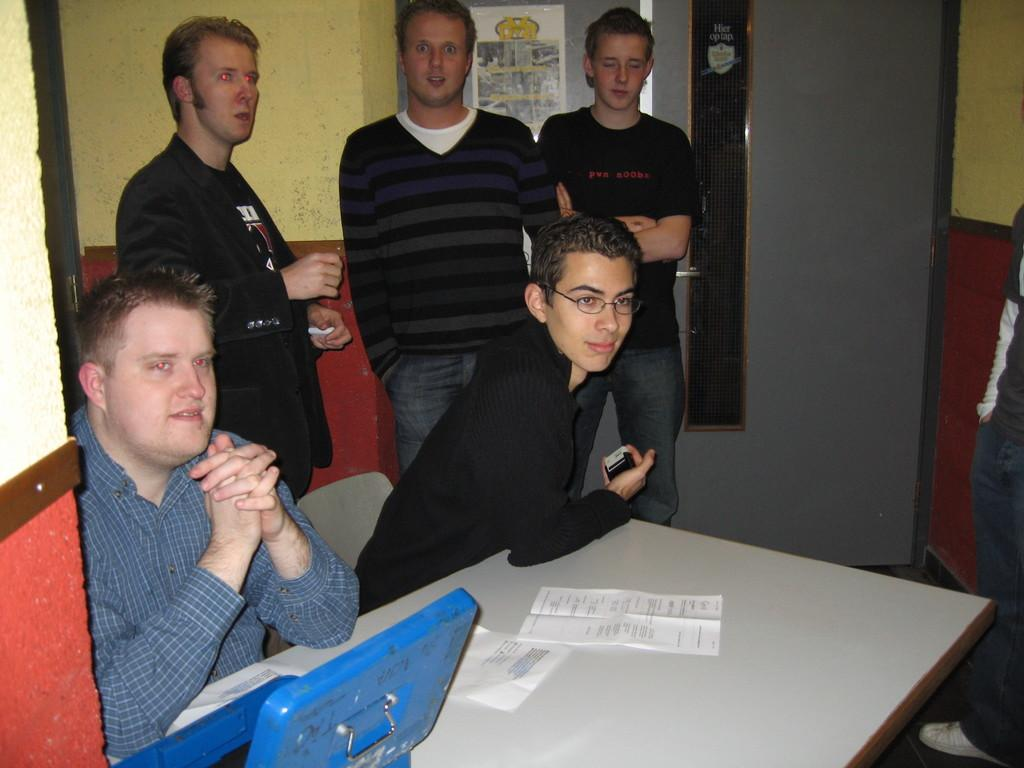How many people are in the image? There is a group of people in the image. What are some of the people in the image doing? Some people are sitting on chairs, while others are standing. What is present on the table in the image? There are papers on the table. What might the people be using the table for? The people might be using the table to hold the papers. What type of pleasure can be seen on the faces of the people in the image? There is no indication of pleasure or emotion on the faces of the people in the image. How many men are present in the image? The provided facts do not specify the gender of the people in the image. Can you see any crows in the image? There are no crows present in the image. 